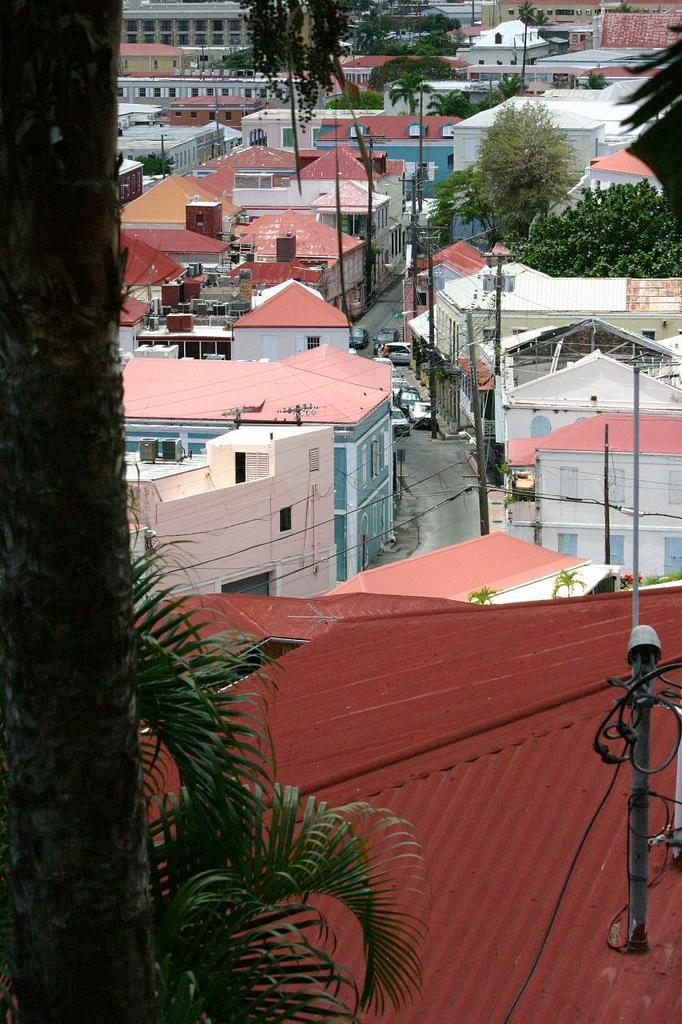What type of structures can be seen in the image? There are many houses in the image. What type of vegetation is present in the image? There are many trees in the image. Are there any vehicles visible in the image? Yes, there are few cars parked on the road. What type of oatmeal is being served to the hen in the image? There is no hen or oatmeal present in the image. Can you describe the speed of the snail in the image? There is no snail present in the image. 